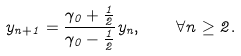<formula> <loc_0><loc_0><loc_500><loc_500>y _ { n + 1 } = \frac { \gamma _ { 0 } + \frac { 1 } { 2 } } { \gamma _ { 0 } - \frac { 1 } { 2 } } y _ { n } , \quad \forall n \geq 2 .</formula> 